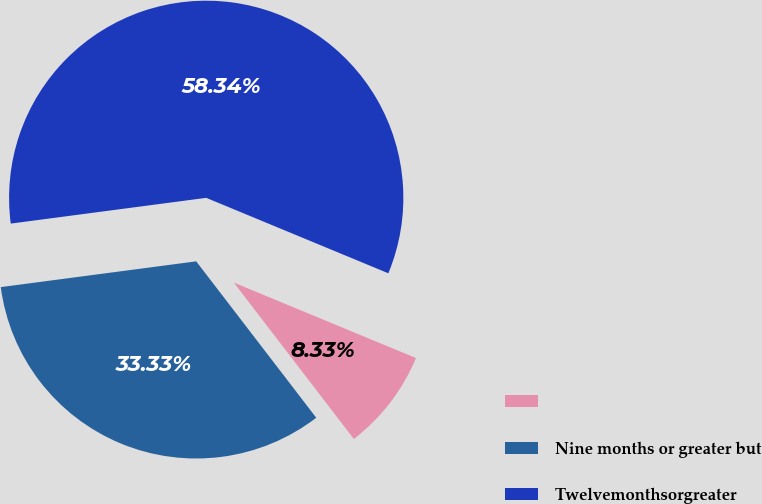<chart> <loc_0><loc_0><loc_500><loc_500><pie_chart><ecel><fcel>Nine months or greater but<fcel>Twelvemonthsorgreater<nl><fcel>8.33%<fcel>33.33%<fcel>58.33%<nl></chart> 